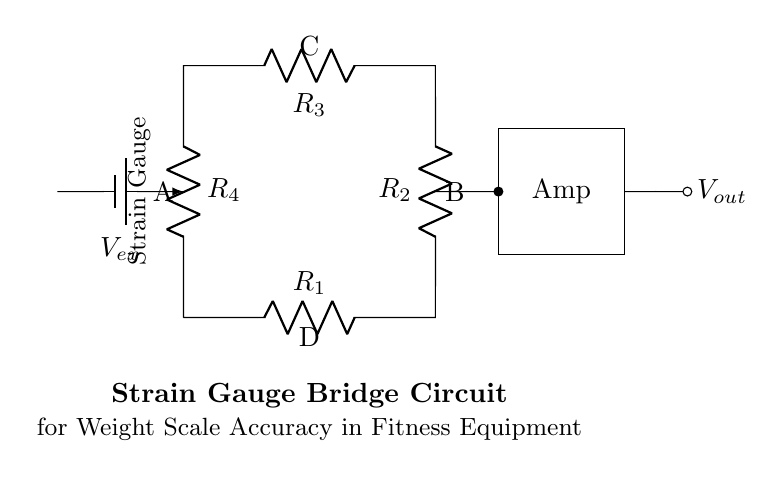What type of circuit is depicted? The circuit shown is a bridge circuit, specifically a strain gauge bridge used for measuring weights. Its configuration includes resistors and is designed to detect changes in resistance which correlate to weight applied.
Answer: Bridge circuit How many resistors are present in the circuit? There are four resistors in the circuit labeled as R1, R2, R3, and R4. They are arranged in a square formation typical of a bridge circuit.
Answer: Four What is the purpose of the voltage source labeled Vex? The voltage source Vex provides the excitation voltage necessary for the bridge circuit operation, enabling it to measure the resistance changes caused by applied weight.
Answer: Excitation voltage What component amplifies the signal in the circuit? The component referred to as "Amp" in the circuit diagram functions as the signal amplifier, enhancing the small voltage changes detected by the strain gauges for better measurement accuracy.
Answer: Amp What position is the strain gauge located in the circuit? The strain gauge is positioned on the left side of the bridge circuit, it is connected to one of the resistors, allowing it to cause a resistance change when weight is applied.
Answer: Left side How does the output voltage Vout relate to the weight applied? The output voltage Vout varies in accordance with the imbalance in the bridge resulting from the weight applied, reflecting the strain gauge's resistance change. The change in output voltage correlates directly to the weight.
Answer: Varies with weight What does point 'C' represent in this bridge circuit? Point 'C' marks the connection point at the top of the bridge circuit where the resistance R3 is connected, and it plays a role in determining the voltage measurement across the bridge.
Answer: Connection point 